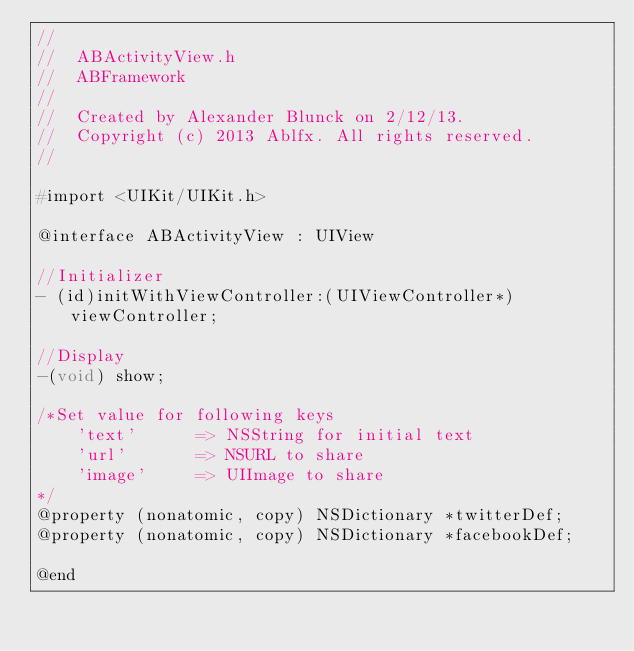<code> <loc_0><loc_0><loc_500><loc_500><_C_>//
//  ABActivityView.h
//  ABFramework
//
//  Created by Alexander Blunck on 2/12/13.
//  Copyright (c) 2013 Ablfx. All rights reserved.
//

#import <UIKit/UIKit.h>

@interface ABActivityView : UIView

//Initializer
- (id)initWithViewController:(UIViewController*)viewController;

//Display
-(void) show;

/*Set value for following keys
    'text'      => NSString for initial text
    'url'       => NSURL to share
    'image'     => UIImage to share
*/
@property (nonatomic, copy) NSDictionary *twitterDef;
@property (nonatomic, copy) NSDictionary *facebookDef;

@end
</code> 